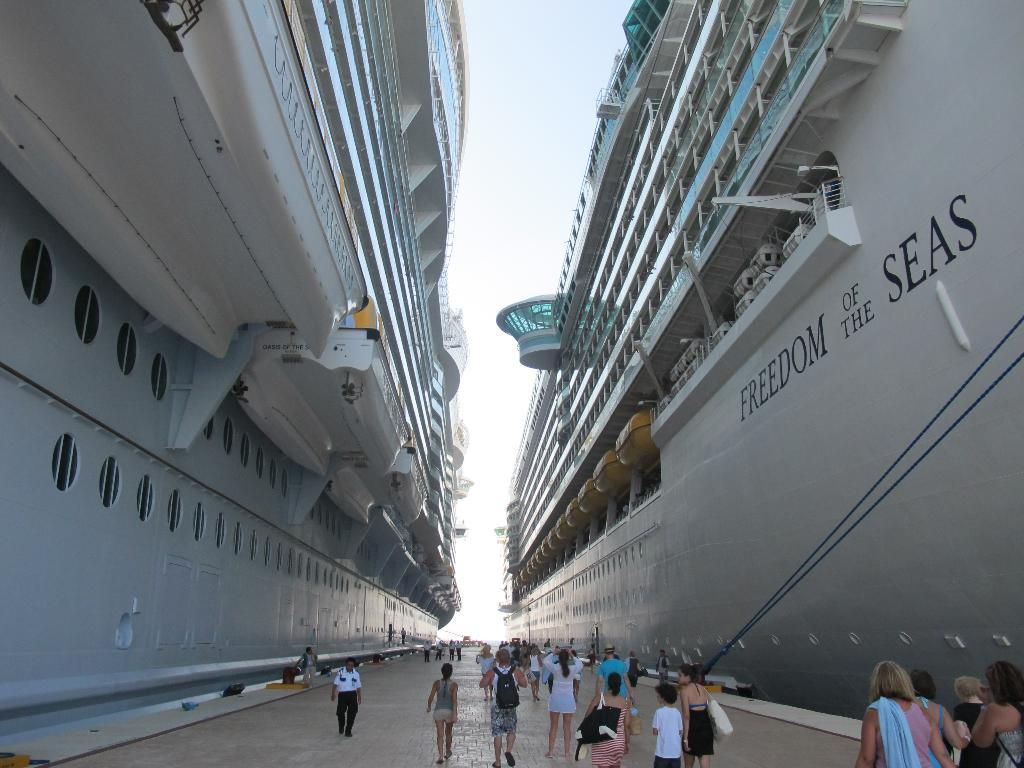<image>
Create a compact narrative representing the image presented. People standing next to a ship which says "Freedom of the Seas". 